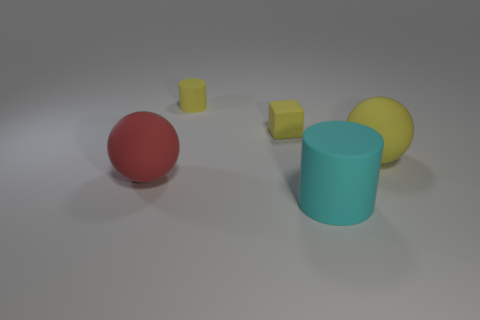Subtract all gray spheres. Subtract all cyan cubes. How many spheres are left? 2 Add 1 big brown shiny blocks. How many objects exist? 6 Subtract all cylinders. How many objects are left? 3 Add 3 cylinders. How many cylinders exist? 5 Subtract 0 cyan blocks. How many objects are left? 5 Subtract all small red things. Subtract all big matte balls. How many objects are left? 3 Add 3 small blocks. How many small blocks are left? 4 